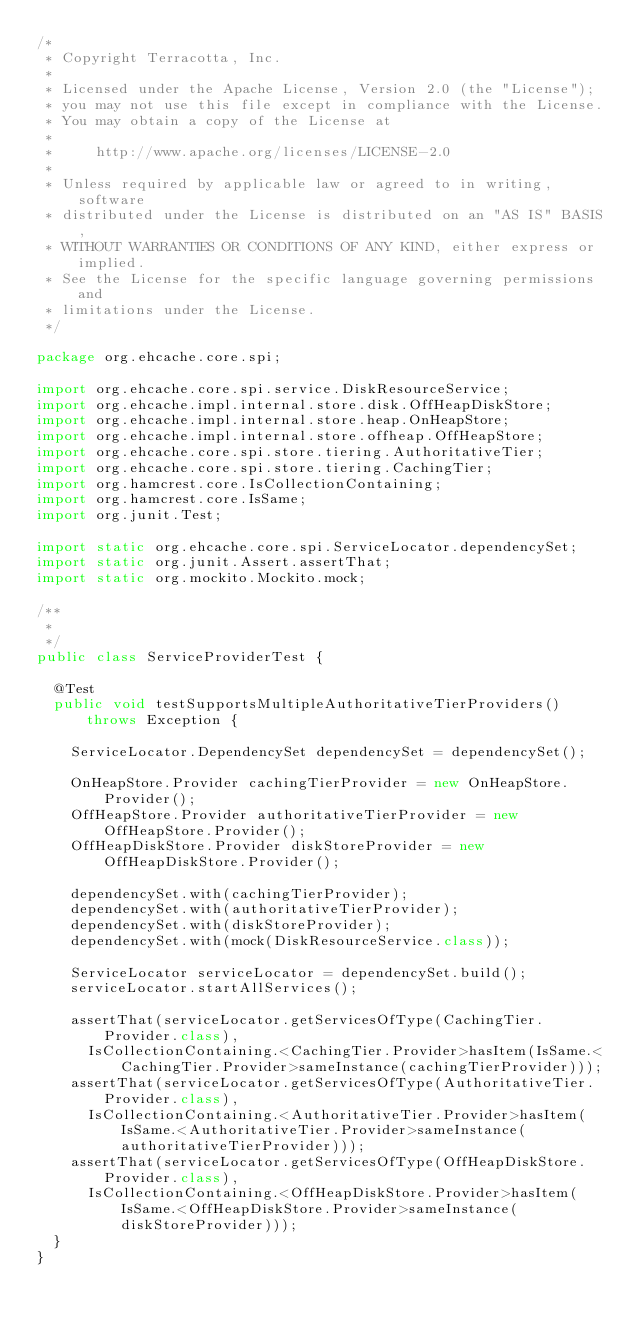Convert code to text. <code><loc_0><loc_0><loc_500><loc_500><_Java_>/*
 * Copyright Terracotta, Inc.
 *
 * Licensed under the Apache License, Version 2.0 (the "License");
 * you may not use this file except in compliance with the License.
 * You may obtain a copy of the License at
 *
 *     http://www.apache.org/licenses/LICENSE-2.0
 *
 * Unless required by applicable law or agreed to in writing, software
 * distributed under the License is distributed on an "AS IS" BASIS,
 * WITHOUT WARRANTIES OR CONDITIONS OF ANY KIND, either express or implied.
 * See the License for the specific language governing permissions and
 * limitations under the License.
 */

package org.ehcache.core.spi;

import org.ehcache.core.spi.service.DiskResourceService;
import org.ehcache.impl.internal.store.disk.OffHeapDiskStore;
import org.ehcache.impl.internal.store.heap.OnHeapStore;
import org.ehcache.impl.internal.store.offheap.OffHeapStore;
import org.ehcache.core.spi.store.tiering.AuthoritativeTier;
import org.ehcache.core.spi.store.tiering.CachingTier;
import org.hamcrest.core.IsCollectionContaining;
import org.hamcrest.core.IsSame;
import org.junit.Test;

import static org.ehcache.core.spi.ServiceLocator.dependencySet;
import static org.junit.Assert.assertThat;
import static org.mockito.Mockito.mock;

/**
 *
 */
public class ServiceProviderTest {

  @Test
  public void testSupportsMultipleAuthoritativeTierProviders() throws Exception {

    ServiceLocator.DependencySet dependencySet = dependencySet();

    OnHeapStore.Provider cachingTierProvider = new OnHeapStore.Provider();
    OffHeapStore.Provider authoritativeTierProvider = new OffHeapStore.Provider();
    OffHeapDiskStore.Provider diskStoreProvider = new OffHeapDiskStore.Provider();

    dependencySet.with(cachingTierProvider);
    dependencySet.with(authoritativeTierProvider);
    dependencySet.with(diskStoreProvider);
    dependencySet.with(mock(DiskResourceService.class));

    ServiceLocator serviceLocator = dependencySet.build();
    serviceLocator.startAllServices();

    assertThat(serviceLocator.getServicesOfType(CachingTier.Provider.class),
      IsCollectionContaining.<CachingTier.Provider>hasItem(IsSame.<CachingTier.Provider>sameInstance(cachingTierProvider)));
    assertThat(serviceLocator.getServicesOfType(AuthoritativeTier.Provider.class),
      IsCollectionContaining.<AuthoritativeTier.Provider>hasItem(IsSame.<AuthoritativeTier.Provider>sameInstance(authoritativeTierProvider)));
    assertThat(serviceLocator.getServicesOfType(OffHeapDiskStore.Provider.class),
      IsCollectionContaining.<OffHeapDiskStore.Provider>hasItem(IsSame.<OffHeapDiskStore.Provider>sameInstance(diskStoreProvider)));
  }
}
</code> 